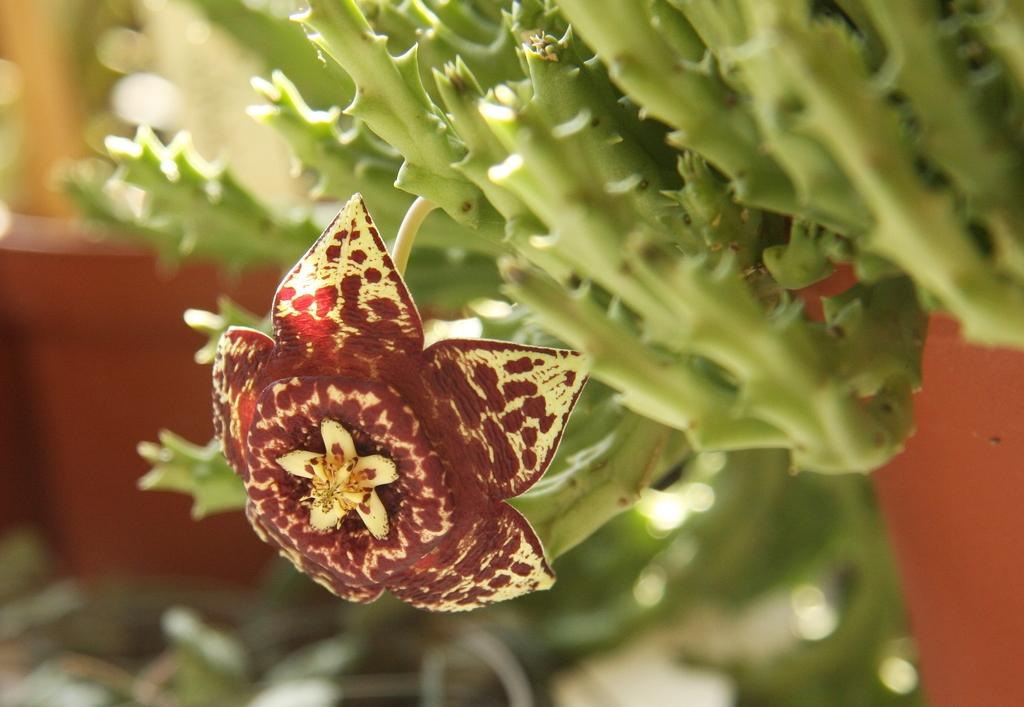What is the main subject in the center of the image? There is a flower on a plant in the center of the image. Can you describe any other plants visible in the image? Yes, there is a house plant in the background of the image. How many trains can be seen passing through the yard in the image? There are no trains or yards present in the image; it features a flower on a plant and a house plant. What type of silk is draped over the flower in the image? There is no silk present in the image; it features a flower on a plant and a house plant. 